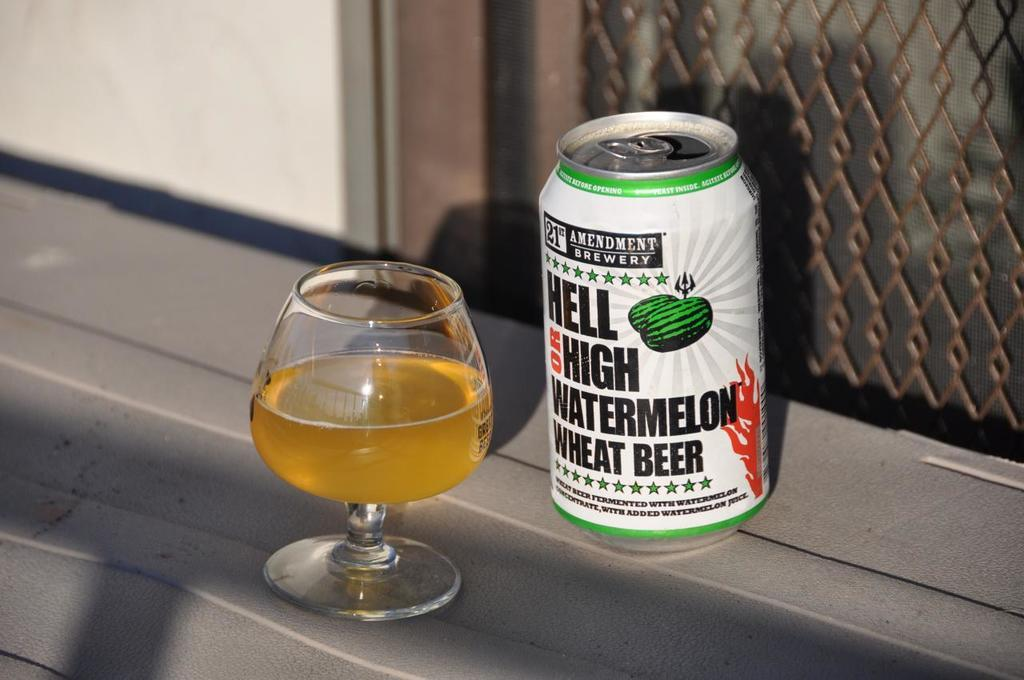<image>
Describe the image concisely. A can of watermelon wheat beer next to a glass 